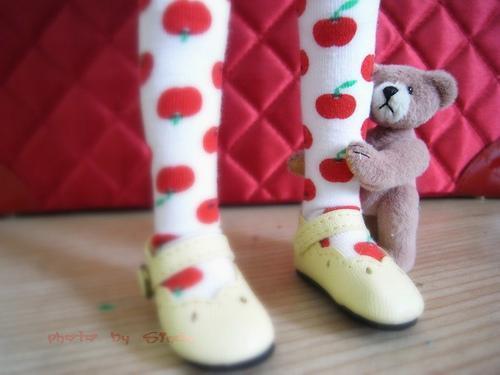Is the given caption "The teddy bear is in front of the person." fitting for the image?
Answer yes or no. No. Is this affirmation: "The teddy bear is below the person." correct?
Answer yes or no. Yes. 